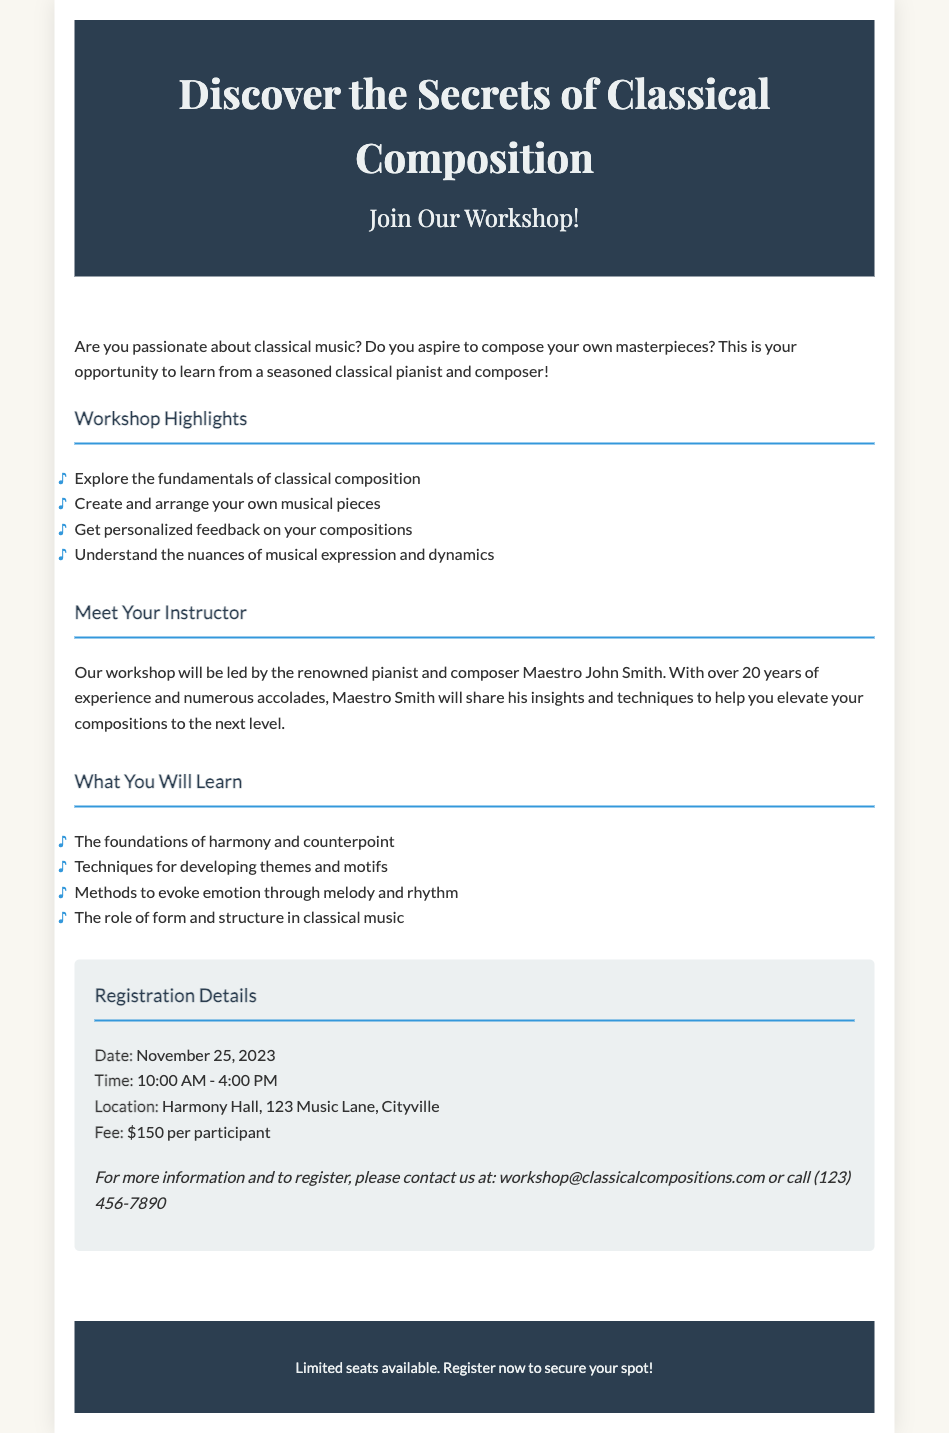What is the title of the workshop? The title of the workshop is prominently displayed at the top of the document, indicating the main focus of the event.
Answer: Discover the Secrets of Classical Composition Who is the instructor of the workshop? The document specifies the instructor's name, highlighting their experience and expertise in classical composition.
Answer: Maestro John Smith What is the fee for the workshop? The document lists the fee required for participation in the workshop, which is detailed in the registration section.
Answer: $150 When is the workshop scheduled to take place? The date of the workshop is provided in the registration details section, clarifying when the event will occur.
Answer: November 25, 2023 What main topic does the workshop cover? The document broadly describes the workshop's purpose, summarizing the overarching theme or subject matter participants will explore.
Answer: Classical composition What time does the workshop start and end? The starting and ending times of the workshop are specified, giving potential participants a clear idea of the schedule.
Answer: 10:00 AM - 4:00 PM Where is the workshop being held? The location of the workshop is explicitly mentioned in the registration section, indicating where attendees should go.
Answer: Harmony Hall, 123 Music Lane, Cityville How long has the instructor been teaching? The instructor's experience is briefly noted in the document, which gives insight into their qualifications and background.
Answer: Over 20 years 